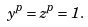<formula> <loc_0><loc_0><loc_500><loc_500>y ^ { p } = z ^ { p } = 1 .</formula> 